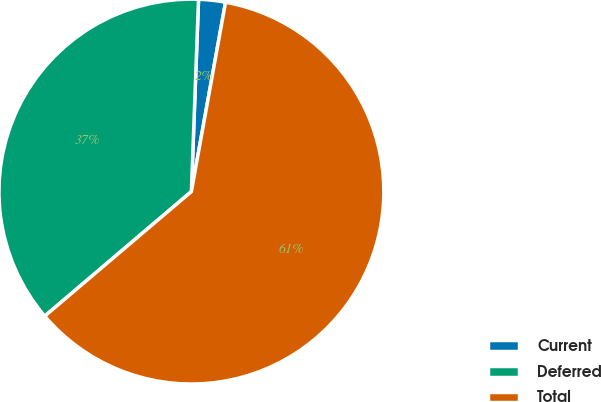Convert chart. <chart><loc_0><loc_0><loc_500><loc_500><pie_chart><fcel>Current<fcel>Deferred<fcel>Total<nl><fcel>2.25%<fcel>36.8%<fcel>60.95%<nl></chart> 